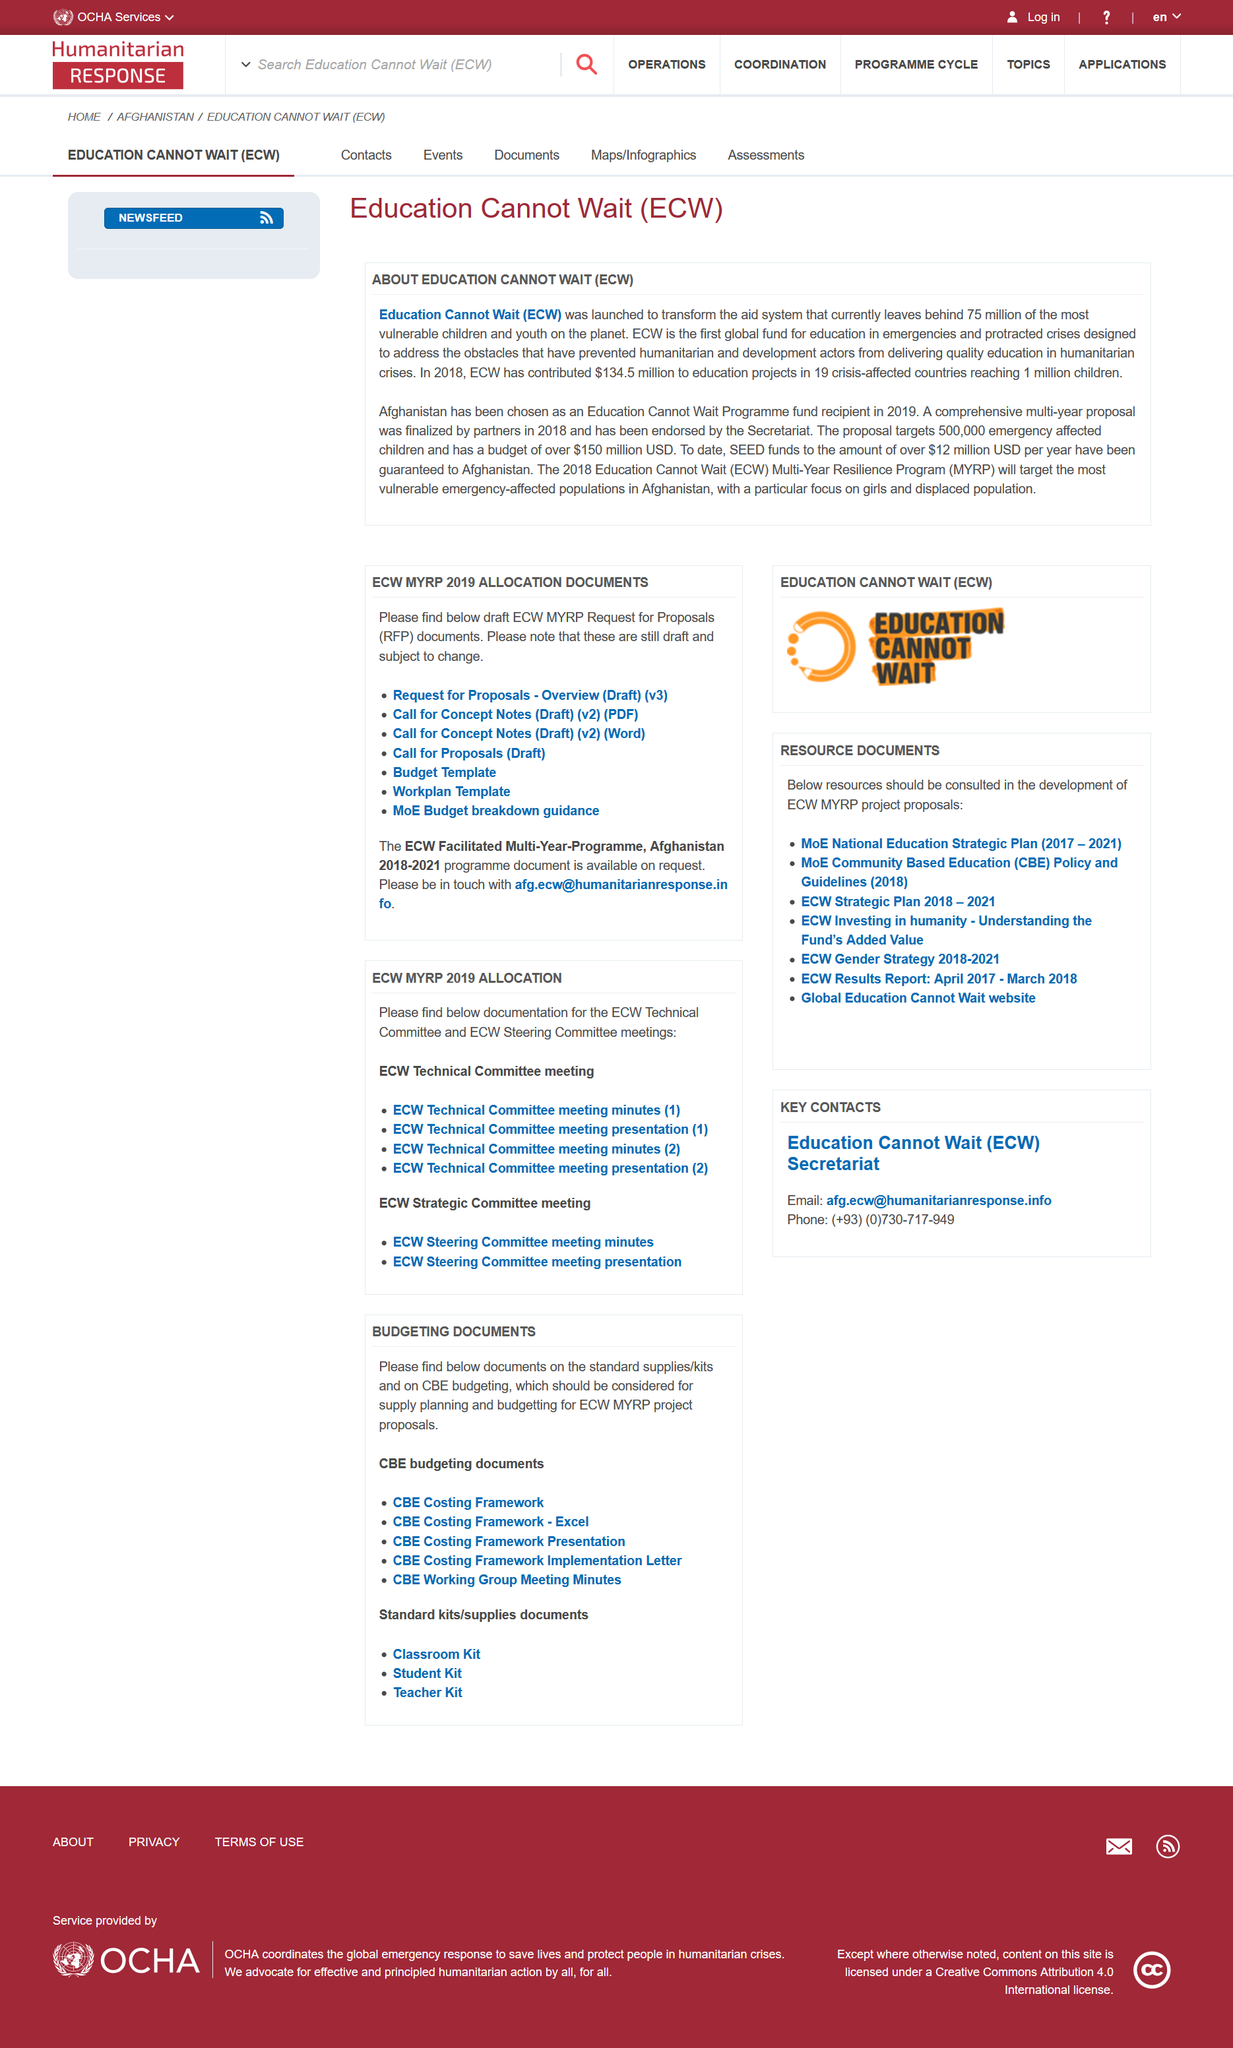Indicate a few pertinent items in this graphic. Afghanistan was chosen by the European Council on Foreign Relations (ECWR) in 2019 as the country that represents the group's interests and ideas in the region. The article at hand pertains to the topic of Education Cannot Wait (ECW), which is a global fund geared towards providing education for children who are vulnerable and in need. In 2018, ECW contributed a total of $134.5 million to various education projects. 